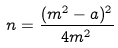Convert formula to latex. <formula><loc_0><loc_0><loc_500><loc_500>n = \frac { ( m ^ { 2 } - a ) ^ { 2 } } { 4 m ^ { 2 } }</formula> 